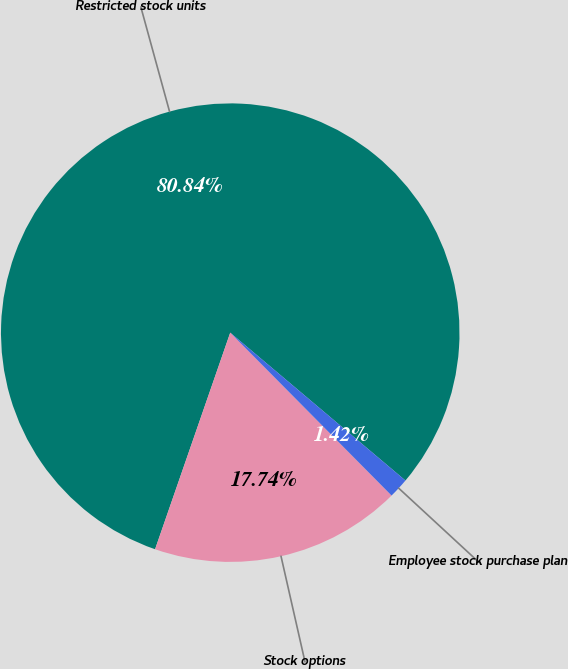Convert chart. <chart><loc_0><loc_0><loc_500><loc_500><pie_chart><fcel>Restricted stock units<fcel>Stock options<fcel>Employee stock purchase plan<nl><fcel>80.84%<fcel>17.74%<fcel>1.42%<nl></chart> 